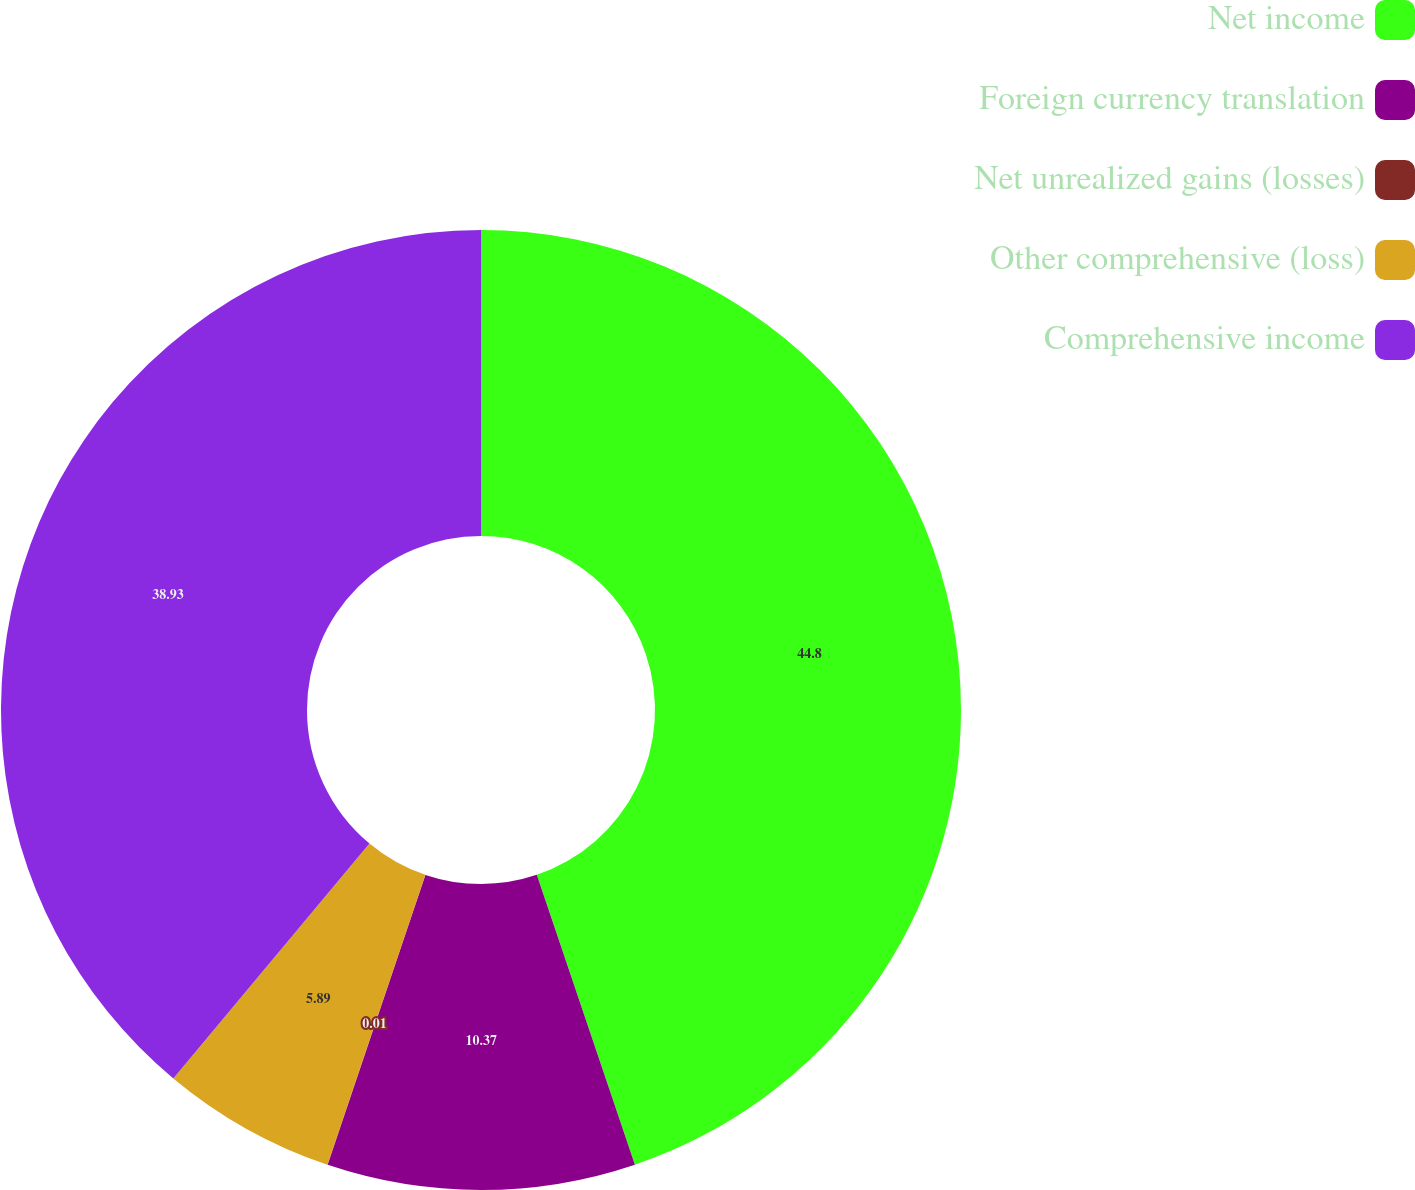<chart> <loc_0><loc_0><loc_500><loc_500><pie_chart><fcel>Net income<fcel>Foreign currency translation<fcel>Net unrealized gains (losses)<fcel>Other comprehensive (loss)<fcel>Comprehensive income<nl><fcel>44.81%<fcel>10.37%<fcel>0.01%<fcel>5.89%<fcel>38.93%<nl></chart> 